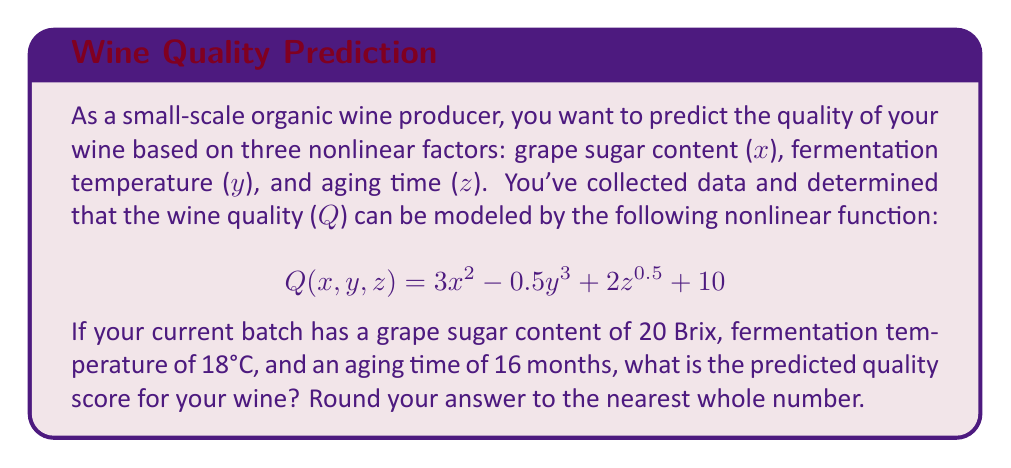Provide a solution to this math problem. To solve this problem, we need to follow these steps:

1. Identify the given values:
   x (grape sugar content) = 20 Brix
   y (fermentation temperature) = 18°C
   z (aging time) = 16 months

2. Substitute these values into the given function:
   $$Q(20, 18, 16) = 3(20)^2 - 0.5(18)^3 + 2(16)^{0.5} + 10$$

3. Calculate each term:
   a. $3(20)^2 = 3 \times 400 = 1200$
   b. $0.5(18)^3 = 0.5 \times 5832 = 2916$
   c. $2(16)^{0.5} = 2 \times 4 = 8$

4. Combine the terms:
   $$Q(20, 18, 16) = 1200 - 2916 + 8 + 10$$

5. Calculate the final result:
   $$Q(20, 18, 16) = -1698$$

6. Round to the nearest whole number:
   $-1698$ rounds to $-1698$

Therefore, the predicted quality score for your wine is -1698.
Answer: -1698 